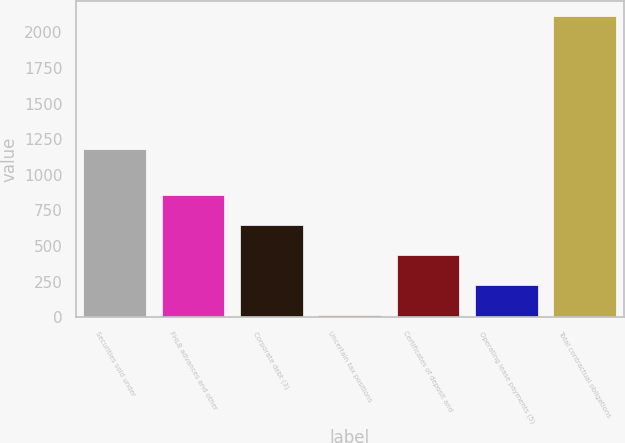Convert chart to OTSL. <chart><loc_0><loc_0><loc_500><loc_500><bar_chart><fcel>Securities sold under<fcel>FHLB advances and other<fcel>Corporate debt (3)<fcel>Uncertain tax positions<fcel>Certificates of deposit and<fcel>Operating lease payments (5)<fcel>Total contractual obligations<nl><fcel>1178.3<fcel>855.02<fcel>645.54<fcel>17.1<fcel>436.06<fcel>226.58<fcel>2111.9<nl></chart> 